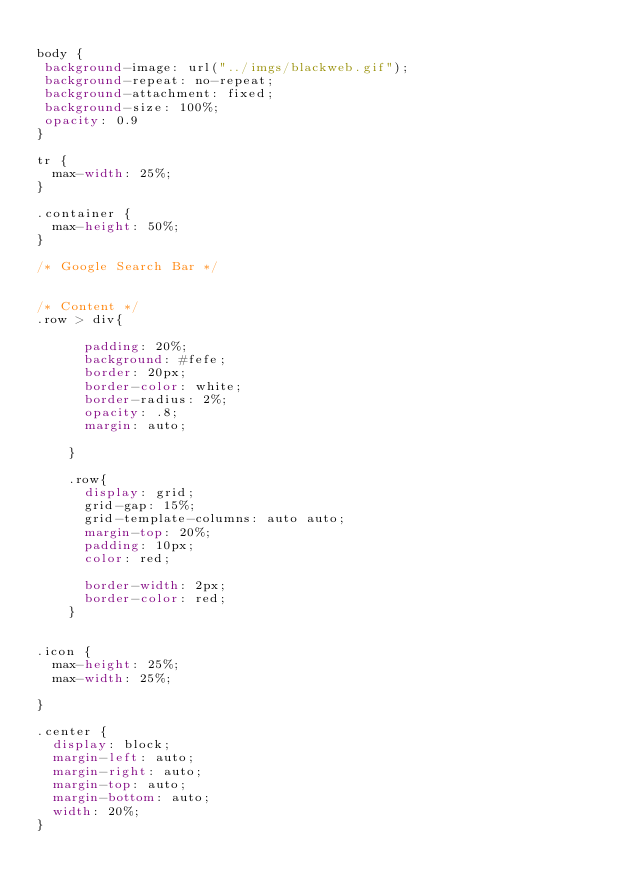<code> <loc_0><loc_0><loc_500><loc_500><_CSS_>
body {
 background-image: url("../imgs/blackweb.gif");
 background-repeat: no-repeat;
 background-attachment: fixed;
 background-size: 100%;
 opacity: 0.9
}

tr {
  max-width: 25%;
}

.container {
  max-height: 50%;
}

/* Google Search Bar */


/* Content */
.row > div{

      padding: 20%;
      background: #fefe;
      border: 20px;
      border-color: white;
      border-radius: 2%;
      opacity: .8;
      margin: auto;

    }

    .row{
      display: grid;
      grid-gap: 15%;
      grid-template-columns: auto auto;
      margin-top: 20%;
      padding: 10px;
      color: red;

      border-width: 2px;
      border-color: red;
    }


.icon {
  max-height: 25%;
  max-width: 25%;

}

.center {
  display: block;
  margin-left: auto;
  margin-right: auto;
  margin-top: auto;
  margin-bottom: auto;
  width: 20%;
}
</code> 